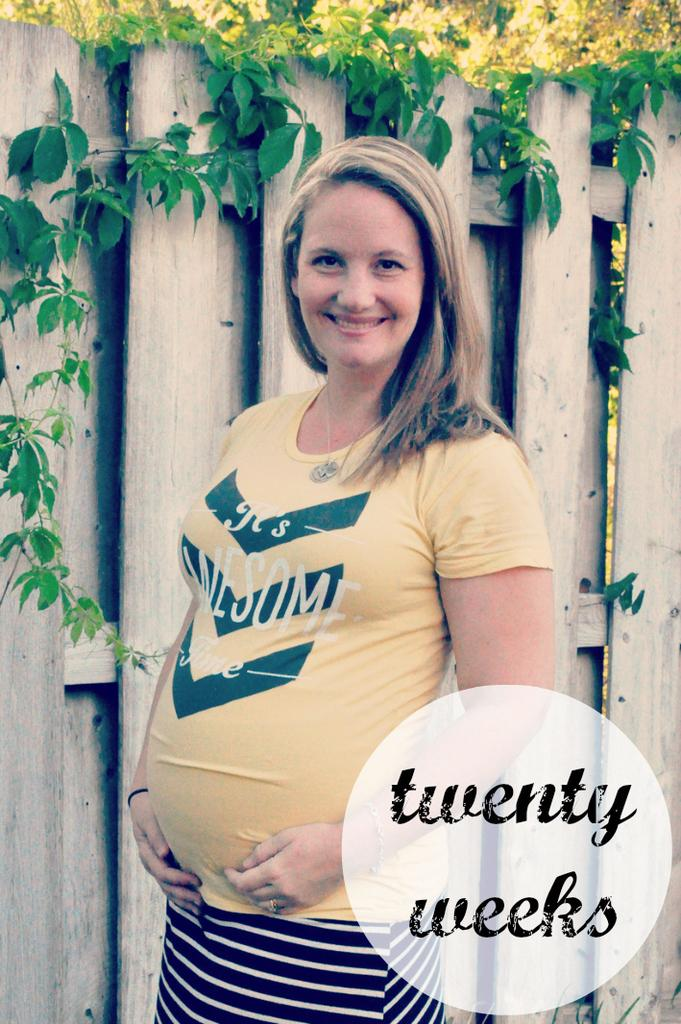Provide a one-sentence caption for the provided image. The sign tells how many weeks pregnant the woman is. 